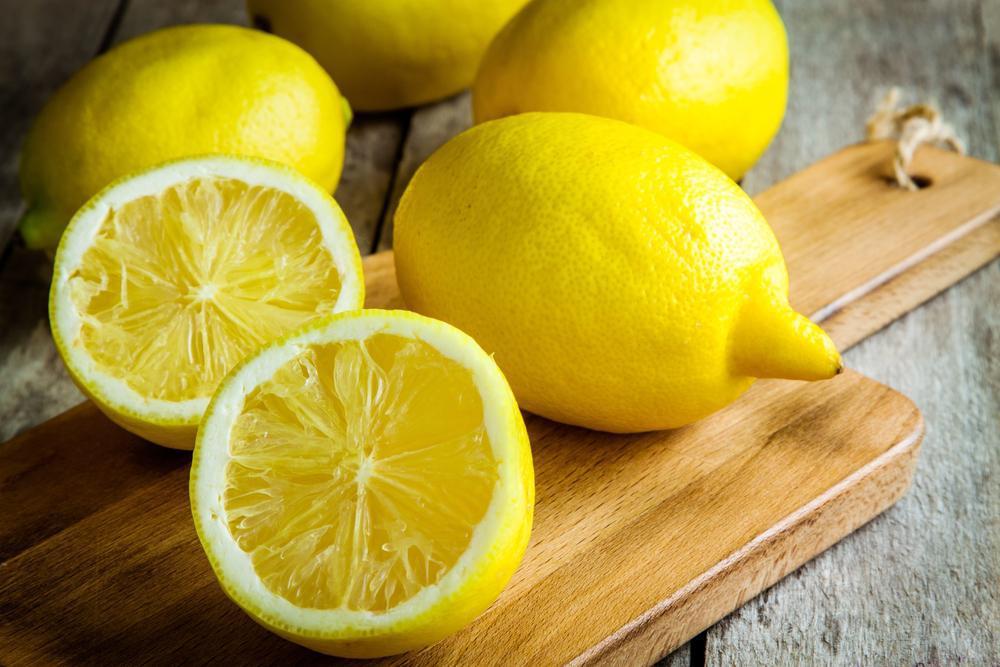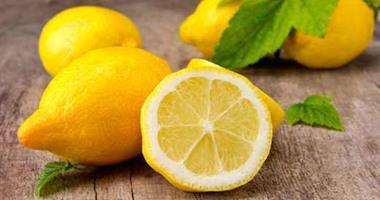The first image is the image on the left, the second image is the image on the right. Examine the images to the left and right. Is the description "There are exactly three uncut lemons." accurate? Answer yes or no. No. The first image is the image on the left, the second image is the image on the right. Examine the images to the left and right. Is the description "Each image contains green leaves, lemon half, and whole lemon." accurate? Answer yes or no. No. 